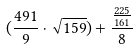<formula> <loc_0><loc_0><loc_500><loc_500>( \frac { 4 9 1 } { 9 } \cdot \sqrt { 1 5 9 } ) + \frac { \frac { 2 2 5 } { 1 6 1 } } { 8 }</formula> 